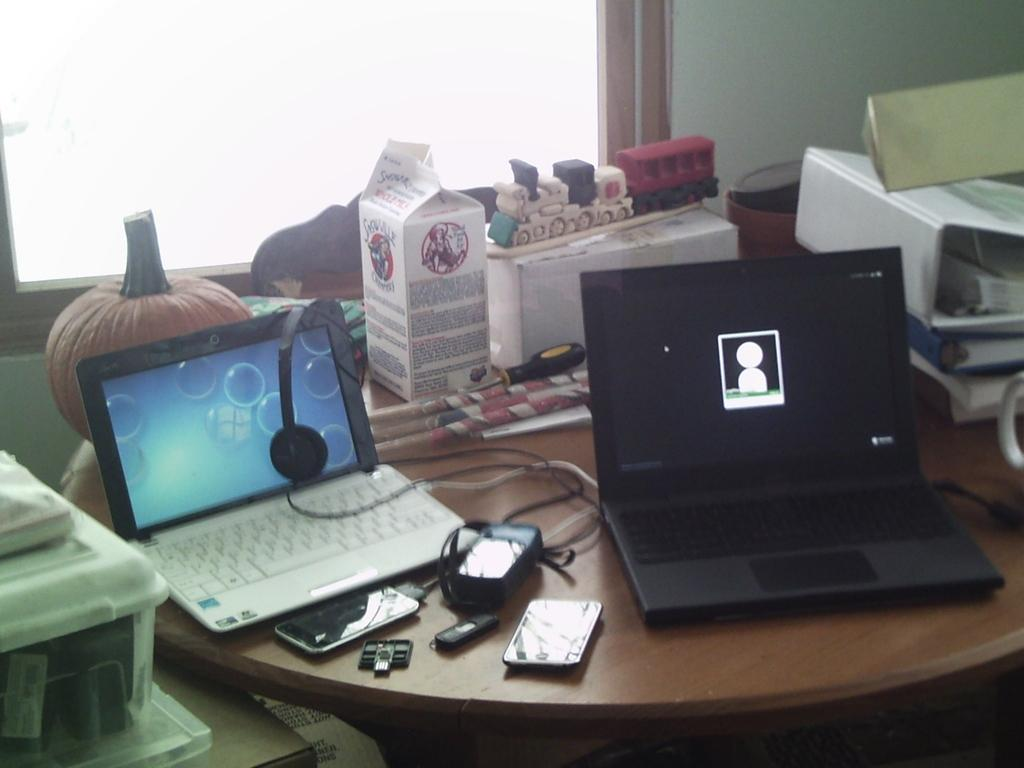What electronic devices are on the table in the image? There are laptops and mobile phones on the table in the image. Are there any other items on the table besides the laptops and mobile phones? Yes, there are other unspecified items on the table. What type of respect can be seen in the image? There is no indication of respect in the image, as it only shows electronic devices and unspecified items on a table. 